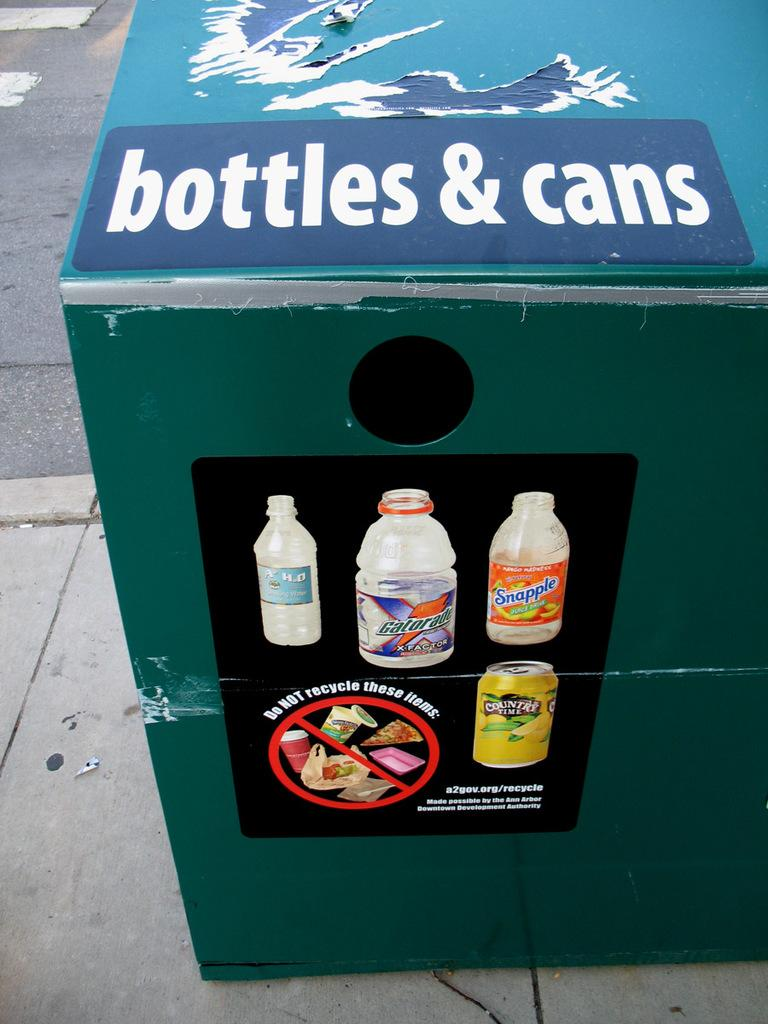<image>
Render a clear and concise summary of the photo. A recycling bin for bottles & cans has the url a2gov.org/recycle at the bottom of its sign. 